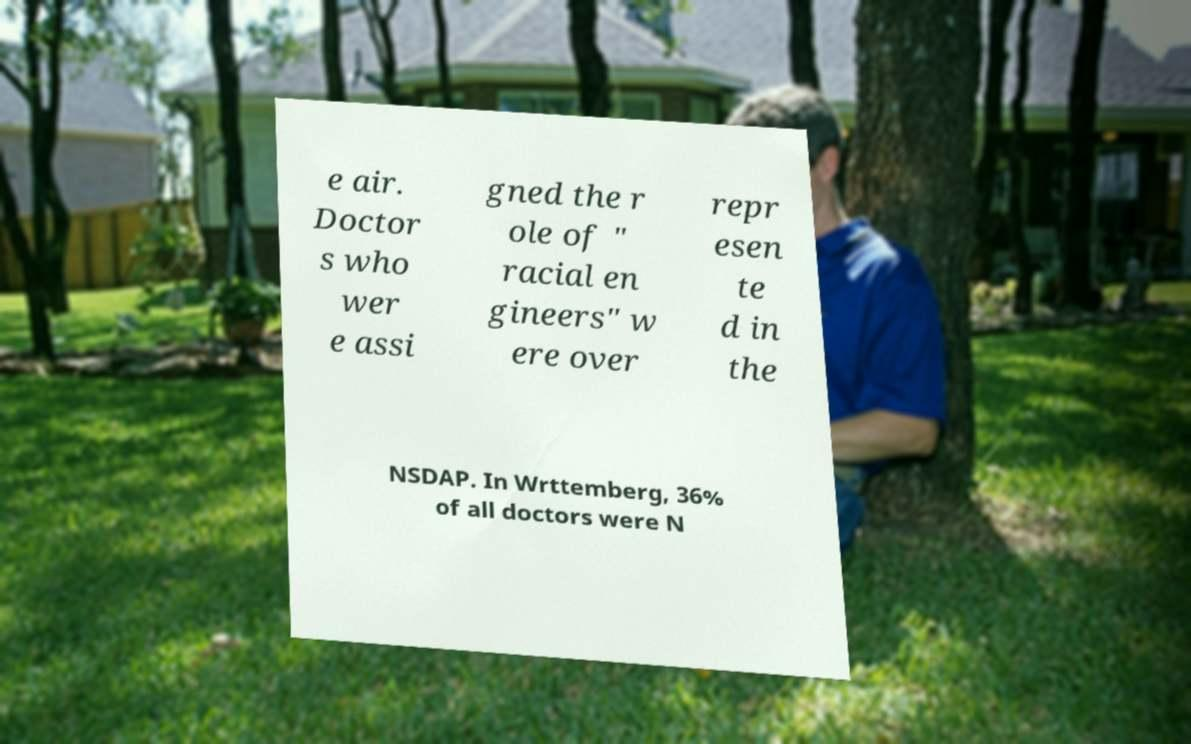For documentation purposes, I need the text within this image transcribed. Could you provide that? e air. Doctor s who wer e assi gned the r ole of " racial en gineers" w ere over repr esen te d in the NSDAP. In Wrttemberg, 36% of all doctors were N 